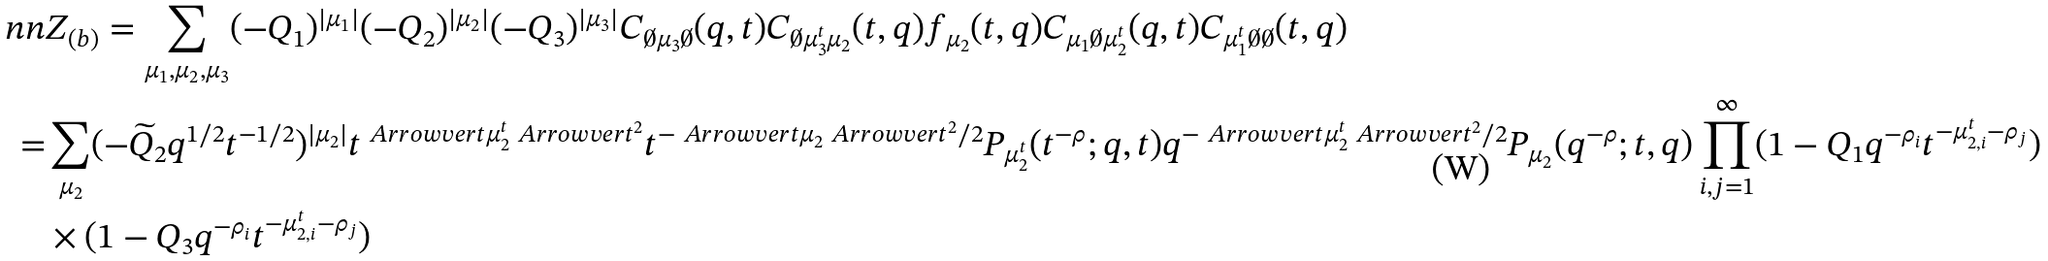<formula> <loc_0><loc_0><loc_500><loc_500>\ n n & Z _ { ( b ) } = \sum _ { \mu _ { 1 } , \mu _ { 2 } , \mu _ { 3 } } ( - Q _ { 1 } ) ^ { | \mu _ { 1 } | } ( - Q _ { 2 } ) ^ { | \mu _ { 2 } | } ( - Q _ { 3 } ) ^ { | \mu _ { 3 } | } C _ { \emptyset \mu _ { 3 } \emptyset } ( q , t ) C _ { \emptyset \mu _ { 3 } ^ { t } \mu _ { 2 } } ( t , q ) f _ { \mu _ { 2 } } ( t , q ) C _ { \mu _ { 1 } \emptyset \mu _ { 2 } ^ { t } } ( q , t ) C _ { \mu _ { 1 } ^ { t } \emptyset \emptyset } ( t , q ) \\ = & \sum _ { \mu _ { 2 } } ( - { \widetilde { Q } _ { 2 } } q ^ { 1 / 2 } t ^ { - 1 / 2 } ) ^ { | \mu _ { 2 } | } t ^ { \ A r r o w v e r t \mu _ { 2 } ^ { t } \ A r r o w v e r t ^ { 2 } } t ^ { - \ A r r o w v e r t \mu _ { 2 } \ A r r o w v e r t ^ { 2 } / 2 } P _ { \mu _ { 2 } ^ { t } } ( t ^ { - \rho } ; q , t ) q ^ { - \ A r r o w v e r t \mu _ { 2 } ^ { t } \ A r r o w v e r t ^ { 2 } / 2 } P _ { \mu _ { 2 } } ( q ^ { - \rho } ; t , q ) \prod _ { i , j = 1 } ^ { \infty } ( 1 - Q _ { 1 } q ^ { - \rho _ { i } } t ^ { - \mu _ { 2 , i } ^ { t } - \rho _ { j } } ) \\ & \times ( 1 - Q _ { 3 } q ^ { - \rho _ { i } } t ^ { - \mu _ { 2 , i } ^ { t } - \rho _ { j } } )</formula> 